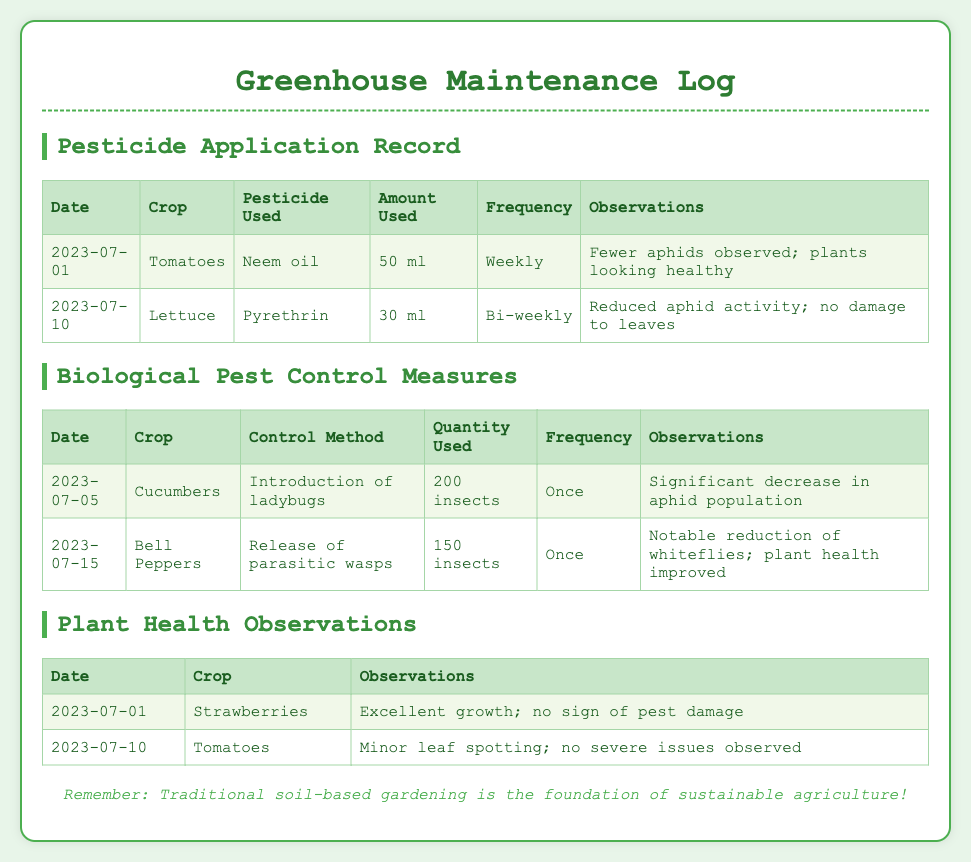What crop was treated with neem oil on July 1, 2023? The document indicates that neem oil was used on tomatoes on July 1, 2023.
Answer: Tomatoes How much pyrethrin was used for lettuce treatment? The table states that 30 ml of pyrethrin was applied to lettuce.
Answer: 30 ml What biological pest control method was used for cucumbers? According to the document, ladybugs were introduced for biological pest control.
Answer: Introduction of ladybugs On which date were ladybugs introduced for cucumbers? The document specifies that ladybugs were introduced on July 5, 2023.
Answer: July 5, 2023 What was observed about the tomato plants on July 10, 2023? The document mentions minor leaf spotting with no severe issues observed.
Answer: Minor leaf spotting; no severe issues observed How often was neem oil applied to tomatoes? The preventive measure log indicates that neem oil was applied weekly.
Answer: Weekly What quantity of parasitic wasps was released for bell peppers? It is noted in the document that 150 insects of parasitic wasps were released for bell peppers.
Answer: 150 insects Which crop showed excellent growth with no pest damage on July 1, 2023? The observations indicate that strawberries exhibited excellent growth with no signs of pest damage.
Answer: Strawberries What was the frequency of pyrethrin application for lettuce? The table specifies that pyrethrin was applied bi-weekly.
Answer: Bi-weekly 